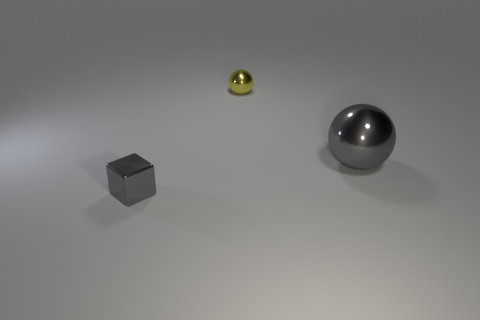Subtract all gray balls. How many balls are left? 1 Add 3 green balls. How many objects exist? 6 Subtract all blocks. How many objects are left? 2 Subtract all green balls. Subtract all brown cylinders. How many balls are left? 2 Subtract all gray blocks. Subtract all small shiny things. How many objects are left? 0 Add 2 tiny cubes. How many tiny cubes are left? 3 Add 1 big gray metallic things. How many big gray metallic things exist? 2 Subtract 0 brown spheres. How many objects are left? 3 